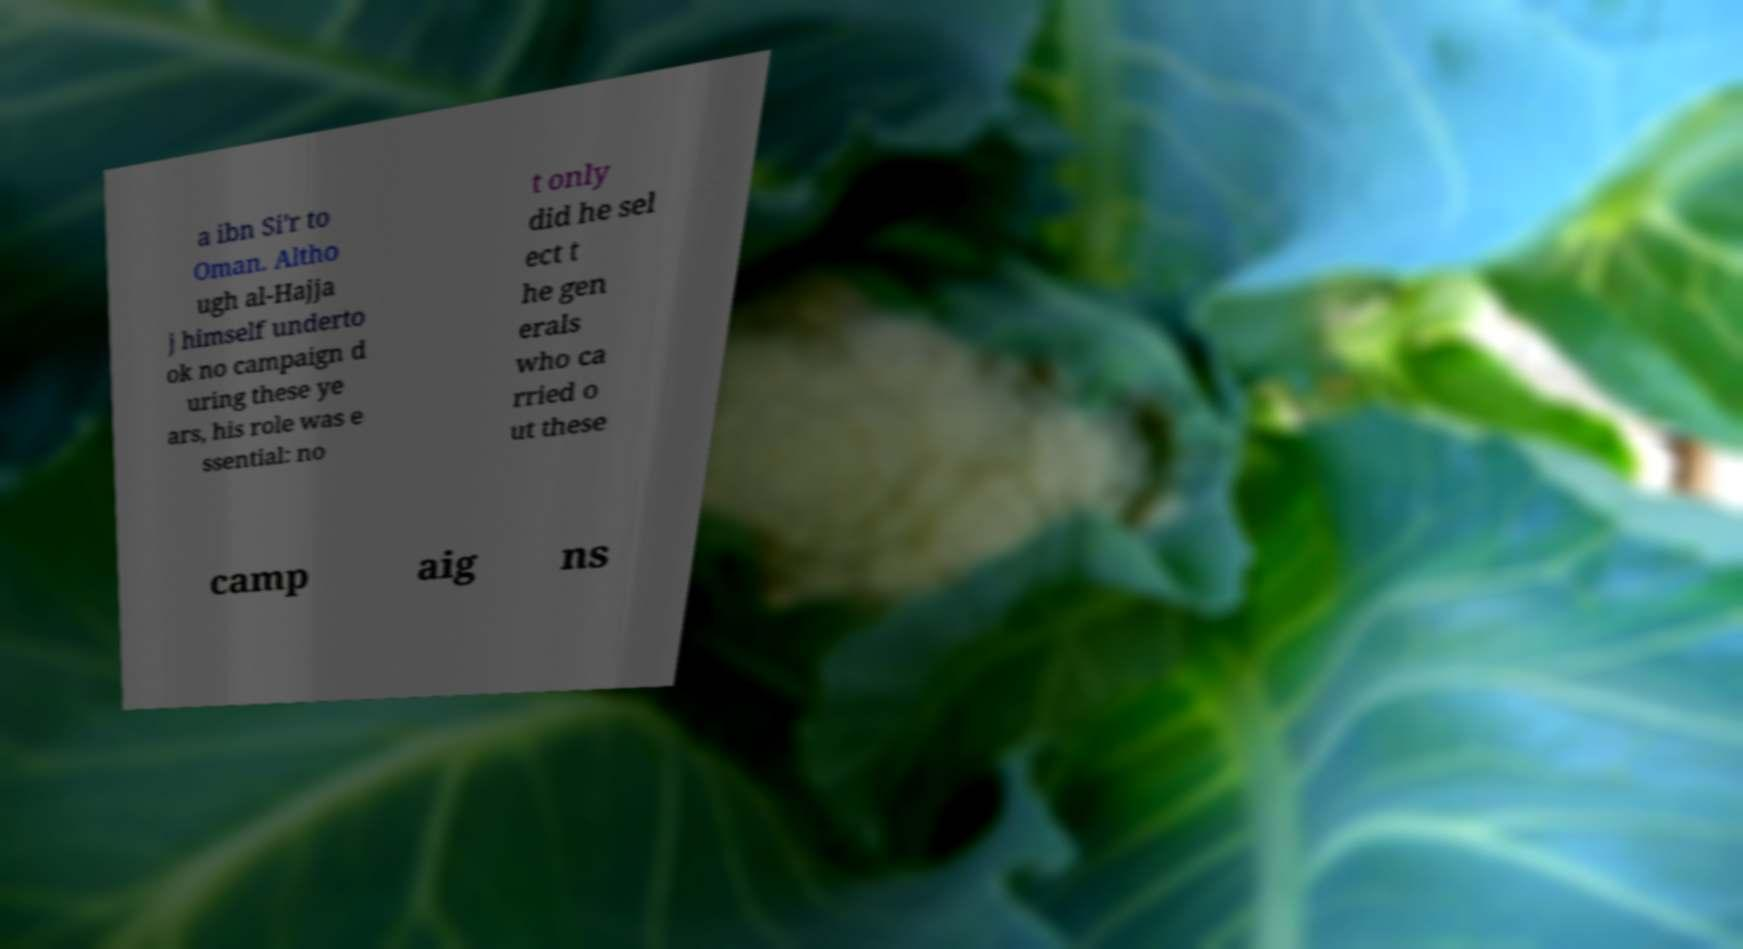There's text embedded in this image that I need extracted. Can you transcribe it verbatim? a ibn Si'r to Oman. Altho ugh al-Hajja j himself underto ok no campaign d uring these ye ars, his role was e ssential: no t only did he sel ect t he gen erals who ca rried o ut these camp aig ns 